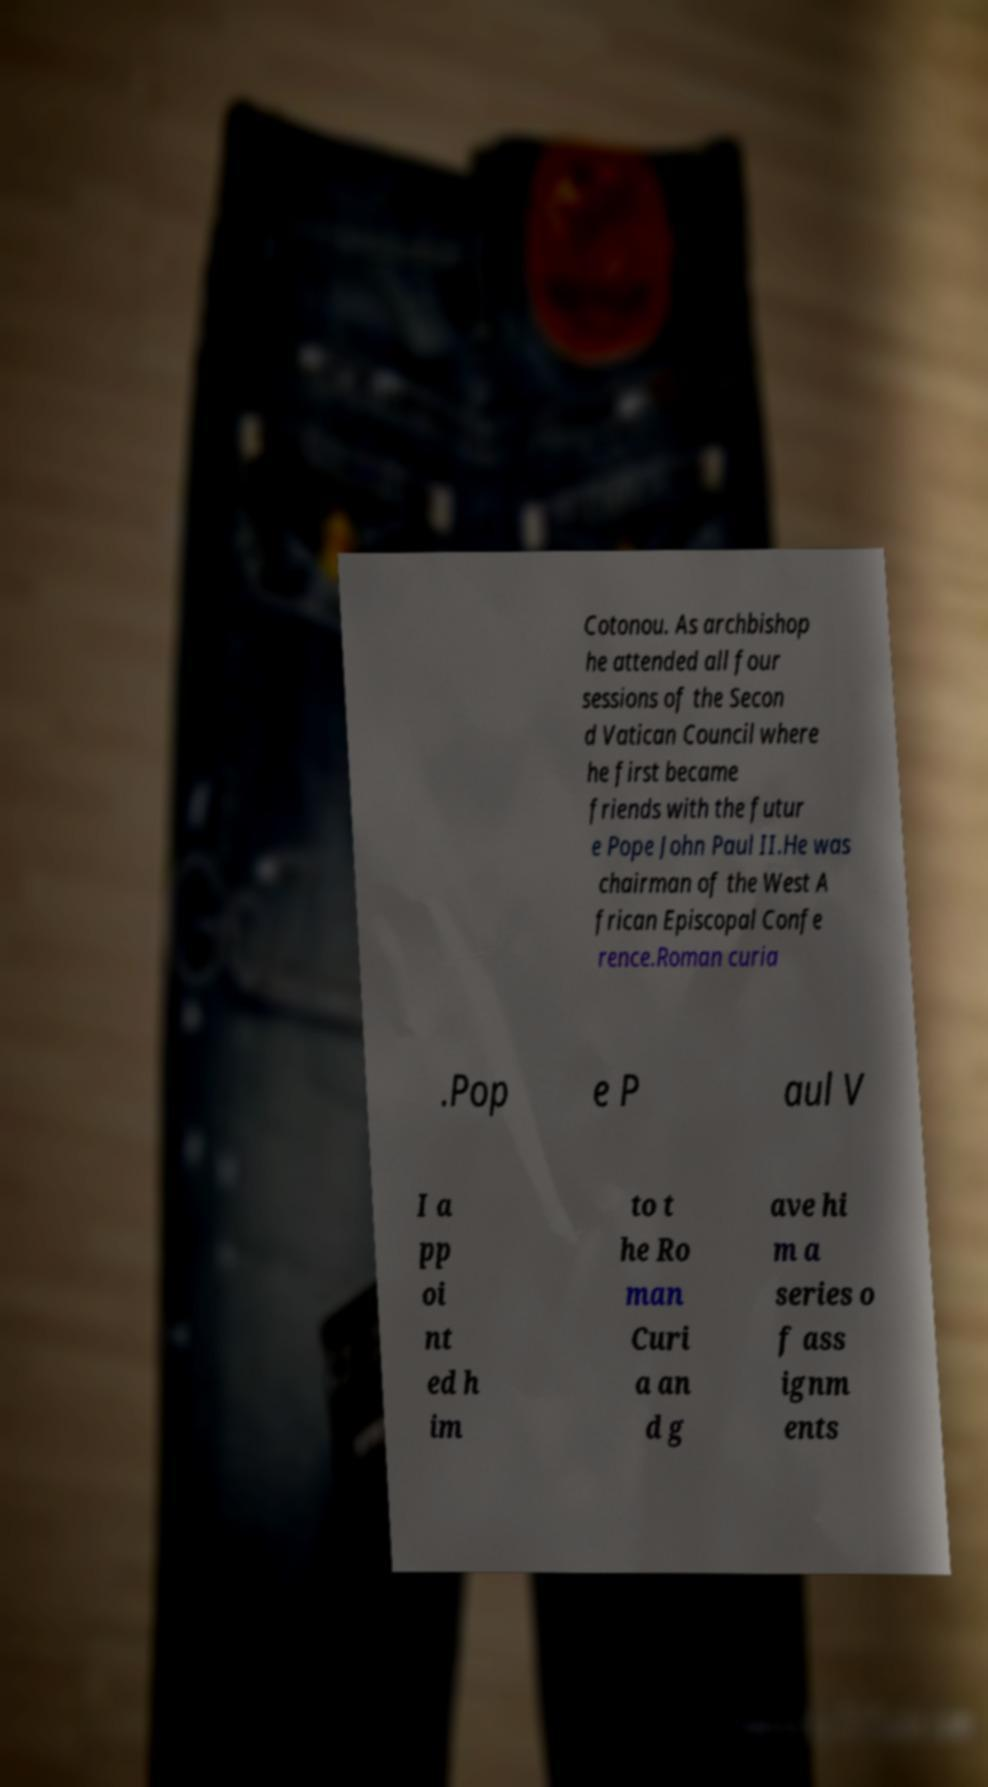What messages or text are displayed in this image? I need them in a readable, typed format. Cotonou. As archbishop he attended all four sessions of the Secon d Vatican Council where he first became friends with the futur e Pope John Paul II.He was chairman of the West A frican Episcopal Confe rence.Roman curia .Pop e P aul V I a pp oi nt ed h im to t he Ro man Curi a an d g ave hi m a series o f ass ignm ents 